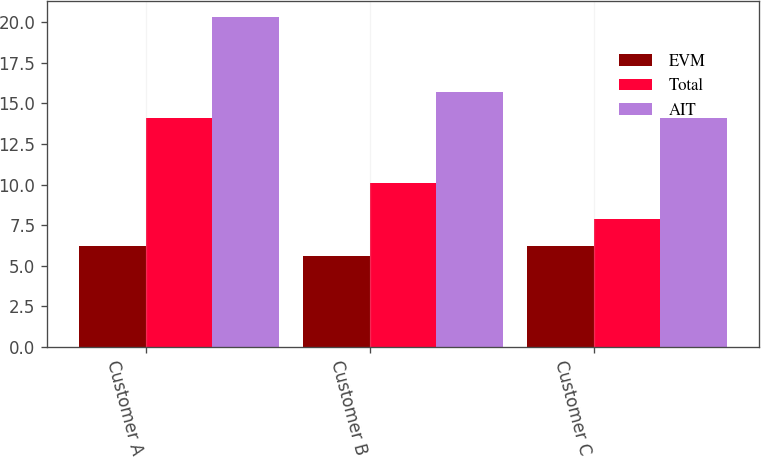Convert chart. <chart><loc_0><loc_0><loc_500><loc_500><stacked_bar_chart><ecel><fcel>Customer A<fcel>Customer B<fcel>Customer C<nl><fcel>EVM<fcel>6.2<fcel>5.6<fcel>6.2<nl><fcel>Total<fcel>14.1<fcel>10.1<fcel>7.9<nl><fcel>AIT<fcel>20.3<fcel>15.7<fcel>14.1<nl></chart> 